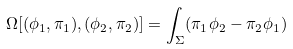Convert formula to latex. <formula><loc_0><loc_0><loc_500><loc_500>\Omega [ ( \phi _ { 1 } , \pi _ { 1 } ) , ( \phi _ { 2 } , \pi _ { 2 } ) ] = \int _ { \Sigma } ( \pi _ { 1 } \phi _ { 2 } - \pi _ { 2 } \phi _ { 1 } )</formula> 